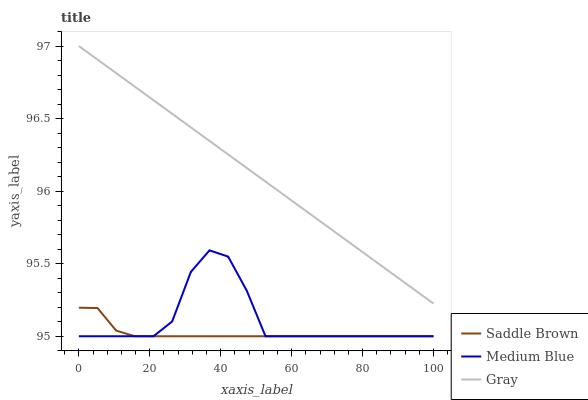Does Saddle Brown have the minimum area under the curve?
Answer yes or no. Yes. Does Gray have the maximum area under the curve?
Answer yes or no. Yes. Does Medium Blue have the minimum area under the curve?
Answer yes or no. No. Does Medium Blue have the maximum area under the curve?
Answer yes or no. No. Is Gray the smoothest?
Answer yes or no. Yes. Is Medium Blue the roughest?
Answer yes or no. Yes. Is Saddle Brown the smoothest?
Answer yes or no. No. Is Saddle Brown the roughest?
Answer yes or no. No. Does Gray have the highest value?
Answer yes or no. Yes. Does Medium Blue have the highest value?
Answer yes or no. No. Is Medium Blue less than Gray?
Answer yes or no. Yes. Is Gray greater than Medium Blue?
Answer yes or no. Yes. Does Medium Blue intersect Saddle Brown?
Answer yes or no. Yes. Is Medium Blue less than Saddle Brown?
Answer yes or no. No. Is Medium Blue greater than Saddle Brown?
Answer yes or no. No. Does Medium Blue intersect Gray?
Answer yes or no. No. 